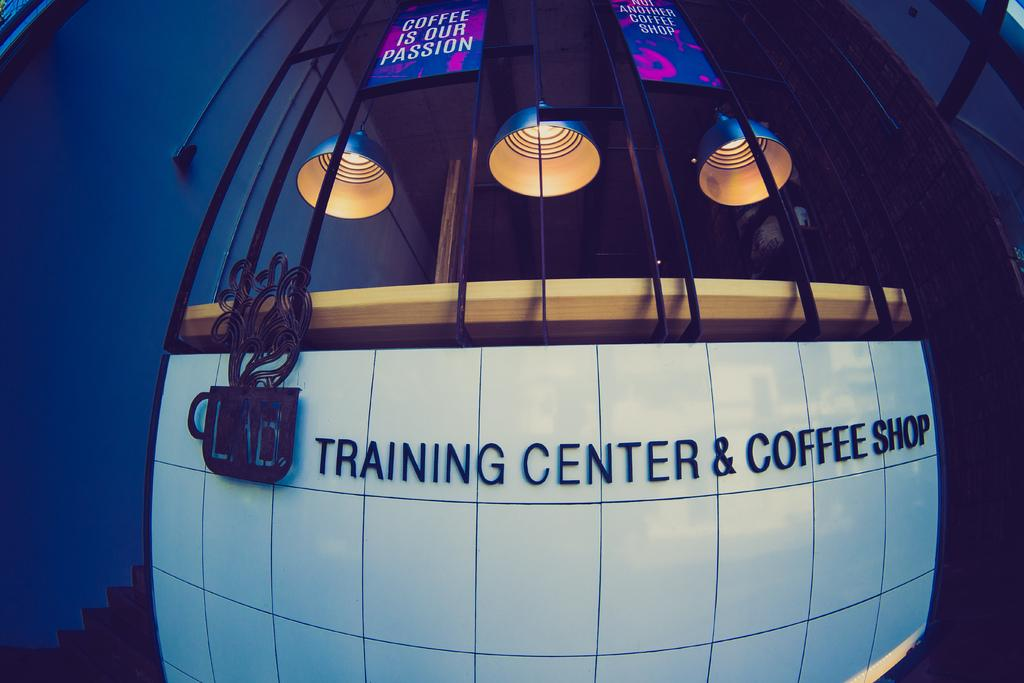<image>
Present a compact description of the photo's key features. "Training Center & Coffee Shop" on ceramic tiles below windows. 